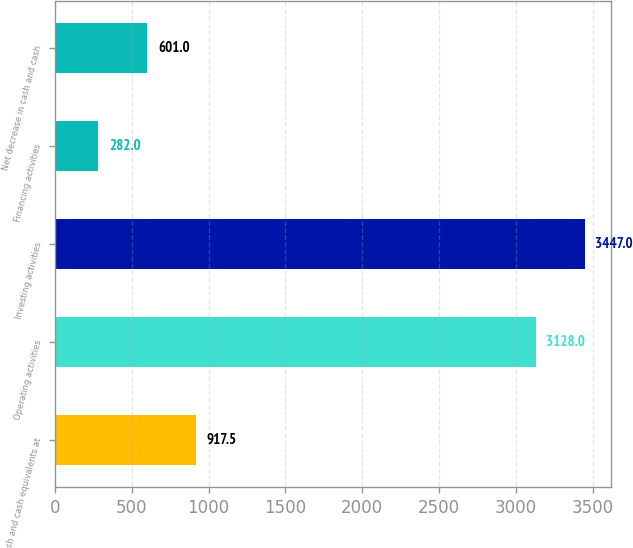Convert chart. <chart><loc_0><loc_0><loc_500><loc_500><bar_chart><fcel>Cash and cash equivalents at<fcel>Operating activities<fcel>Investing activities<fcel>Financing activities<fcel>Net decrease in cash and cash<nl><fcel>917.5<fcel>3128<fcel>3447<fcel>282<fcel>601<nl></chart> 